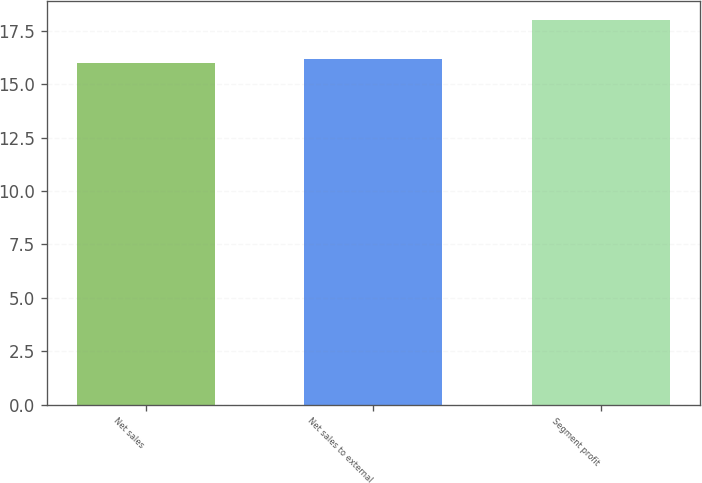Convert chart to OTSL. <chart><loc_0><loc_0><loc_500><loc_500><bar_chart><fcel>Net sales<fcel>Net sales to external<fcel>Segment profit<nl><fcel>16<fcel>16.2<fcel>18<nl></chart> 